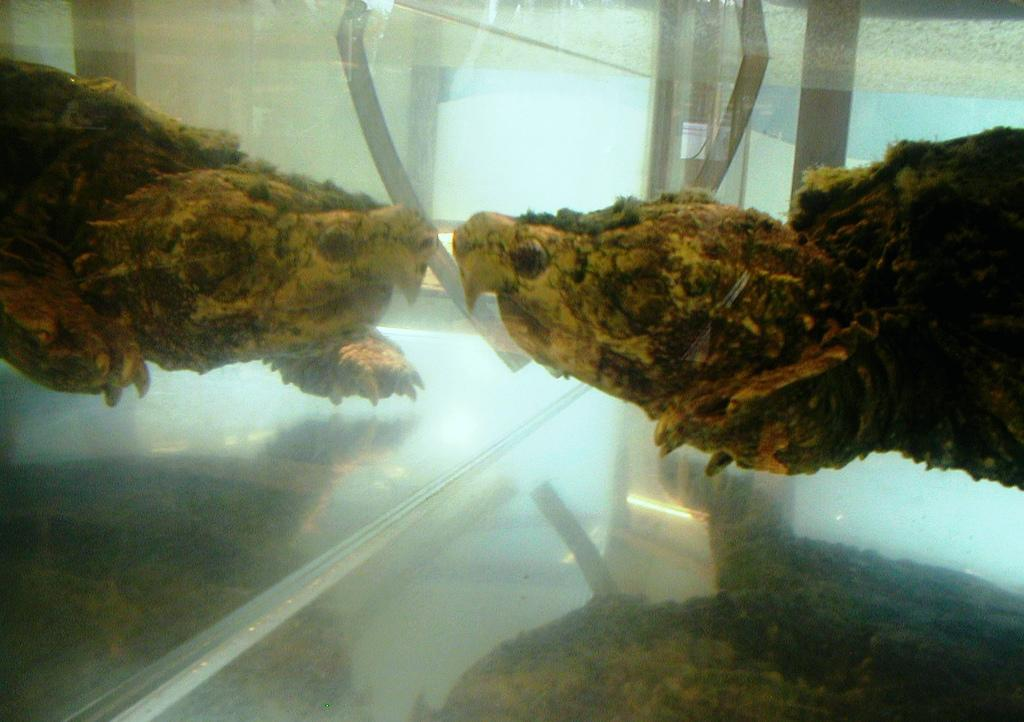What is the main subject of the image? There is an animal in the image. What is visible on the left side of the image? There is a reflection of the animal on the left side of the image. Where is the alley mentioned in the image? There is no alley mentioned or visible in the image. What type of attraction is the animal attending in the image? There is no indication of an attraction or event in the image; it simply features an animal and its reflection. 